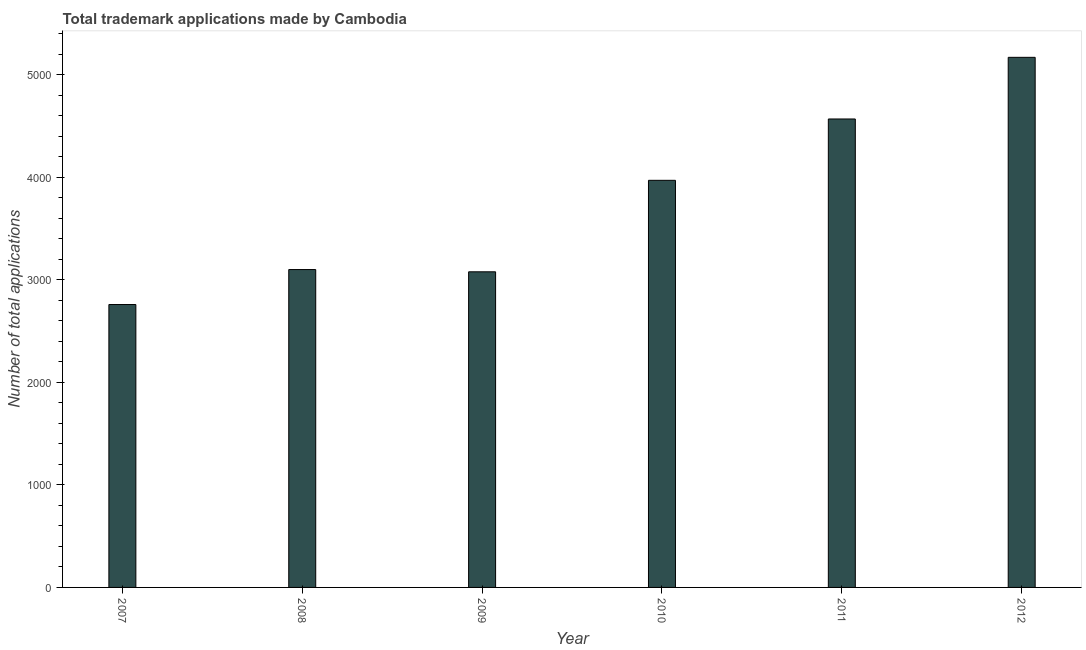Does the graph contain grids?
Ensure brevity in your answer.  No. What is the title of the graph?
Keep it short and to the point. Total trademark applications made by Cambodia. What is the label or title of the X-axis?
Make the answer very short. Year. What is the label or title of the Y-axis?
Make the answer very short. Number of total applications. What is the number of trademark applications in 2007?
Provide a succinct answer. 2758. Across all years, what is the maximum number of trademark applications?
Keep it short and to the point. 5168. Across all years, what is the minimum number of trademark applications?
Provide a succinct answer. 2758. In which year was the number of trademark applications maximum?
Your response must be concise. 2012. What is the sum of the number of trademark applications?
Make the answer very short. 2.26e+04. What is the difference between the number of trademark applications in 2008 and 2010?
Provide a short and direct response. -870. What is the average number of trademark applications per year?
Make the answer very short. 3773. What is the median number of trademark applications?
Give a very brief answer. 3534. What is the ratio of the number of trademark applications in 2007 to that in 2009?
Give a very brief answer. 0.9. What is the difference between the highest and the second highest number of trademark applications?
Provide a succinct answer. 601. Is the sum of the number of trademark applications in 2011 and 2012 greater than the maximum number of trademark applications across all years?
Provide a succinct answer. Yes. What is the difference between the highest and the lowest number of trademark applications?
Keep it short and to the point. 2410. Are all the bars in the graph horizontal?
Your response must be concise. No. How many years are there in the graph?
Your answer should be very brief. 6. What is the difference between two consecutive major ticks on the Y-axis?
Your response must be concise. 1000. What is the Number of total applications in 2007?
Provide a succinct answer. 2758. What is the Number of total applications in 2008?
Ensure brevity in your answer.  3099. What is the Number of total applications in 2009?
Make the answer very short. 3077. What is the Number of total applications in 2010?
Offer a very short reply. 3969. What is the Number of total applications of 2011?
Offer a very short reply. 4567. What is the Number of total applications of 2012?
Make the answer very short. 5168. What is the difference between the Number of total applications in 2007 and 2008?
Offer a very short reply. -341. What is the difference between the Number of total applications in 2007 and 2009?
Provide a succinct answer. -319. What is the difference between the Number of total applications in 2007 and 2010?
Give a very brief answer. -1211. What is the difference between the Number of total applications in 2007 and 2011?
Give a very brief answer. -1809. What is the difference between the Number of total applications in 2007 and 2012?
Provide a succinct answer. -2410. What is the difference between the Number of total applications in 2008 and 2010?
Provide a short and direct response. -870. What is the difference between the Number of total applications in 2008 and 2011?
Keep it short and to the point. -1468. What is the difference between the Number of total applications in 2008 and 2012?
Give a very brief answer. -2069. What is the difference between the Number of total applications in 2009 and 2010?
Ensure brevity in your answer.  -892. What is the difference between the Number of total applications in 2009 and 2011?
Keep it short and to the point. -1490. What is the difference between the Number of total applications in 2009 and 2012?
Keep it short and to the point. -2091. What is the difference between the Number of total applications in 2010 and 2011?
Give a very brief answer. -598. What is the difference between the Number of total applications in 2010 and 2012?
Your response must be concise. -1199. What is the difference between the Number of total applications in 2011 and 2012?
Ensure brevity in your answer.  -601. What is the ratio of the Number of total applications in 2007 to that in 2008?
Provide a short and direct response. 0.89. What is the ratio of the Number of total applications in 2007 to that in 2009?
Offer a very short reply. 0.9. What is the ratio of the Number of total applications in 2007 to that in 2010?
Your answer should be very brief. 0.69. What is the ratio of the Number of total applications in 2007 to that in 2011?
Keep it short and to the point. 0.6. What is the ratio of the Number of total applications in 2007 to that in 2012?
Provide a succinct answer. 0.53. What is the ratio of the Number of total applications in 2008 to that in 2010?
Give a very brief answer. 0.78. What is the ratio of the Number of total applications in 2008 to that in 2011?
Your answer should be compact. 0.68. What is the ratio of the Number of total applications in 2009 to that in 2010?
Your response must be concise. 0.78. What is the ratio of the Number of total applications in 2009 to that in 2011?
Make the answer very short. 0.67. What is the ratio of the Number of total applications in 2009 to that in 2012?
Provide a short and direct response. 0.59. What is the ratio of the Number of total applications in 2010 to that in 2011?
Your answer should be very brief. 0.87. What is the ratio of the Number of total applications in 2010 to that in 2012?
Provide a short and direct response. 0.77. What is the ratio of the Number of total applications in 2011 to that in 2012?
Provide a succinct answer. 0.88. 